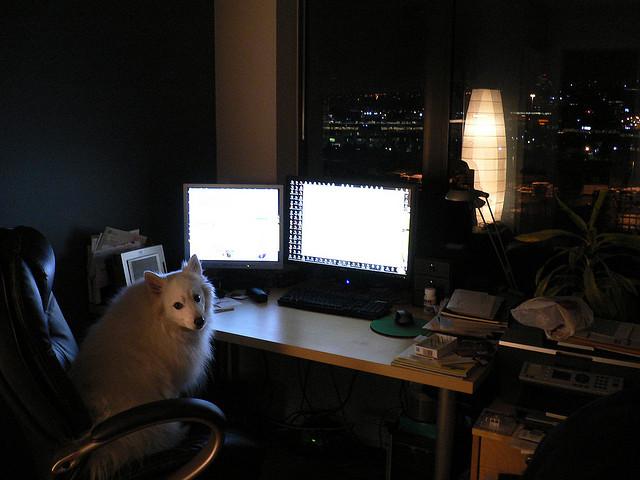Was the dog typing on the computer as the photo was being taken?
Be succinct. No. Are the screens black and white?
Keep it brief. No. What animal is in this picture?
Short answer required. Dog. What type of dog is this?
Keep it brief. Husky. Are the computers on or off?
Quick response, please. On. 